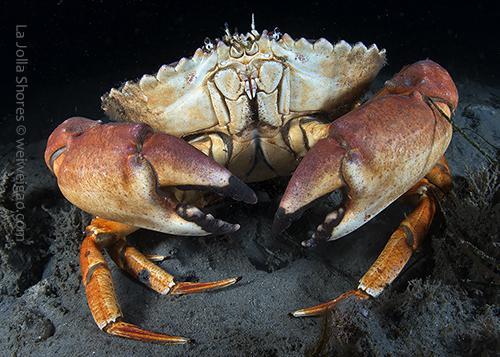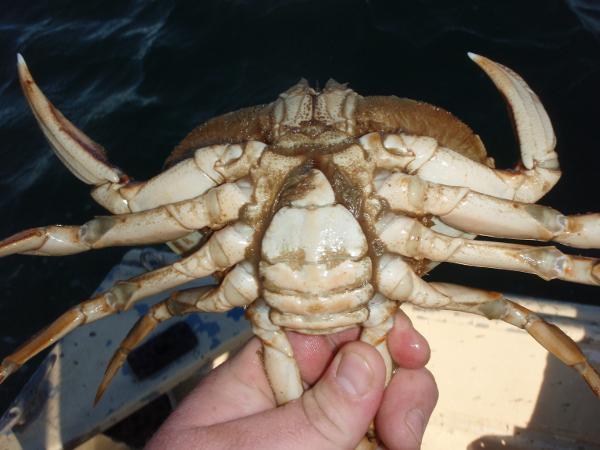The first image is the image on the left, the second image is the image on the right. For the images shown, is this caption "A bare hand is touching two of a crab's claws in one image." true? Answer yes or no. Yes. The first image is the image on the left, the second image is the image on the right. Evaluate the accuracy of this statement regarding the images: "In at least one image there is a single hand holding two of the crabs legs.". Is it true? Answer yes or no. Yes. 